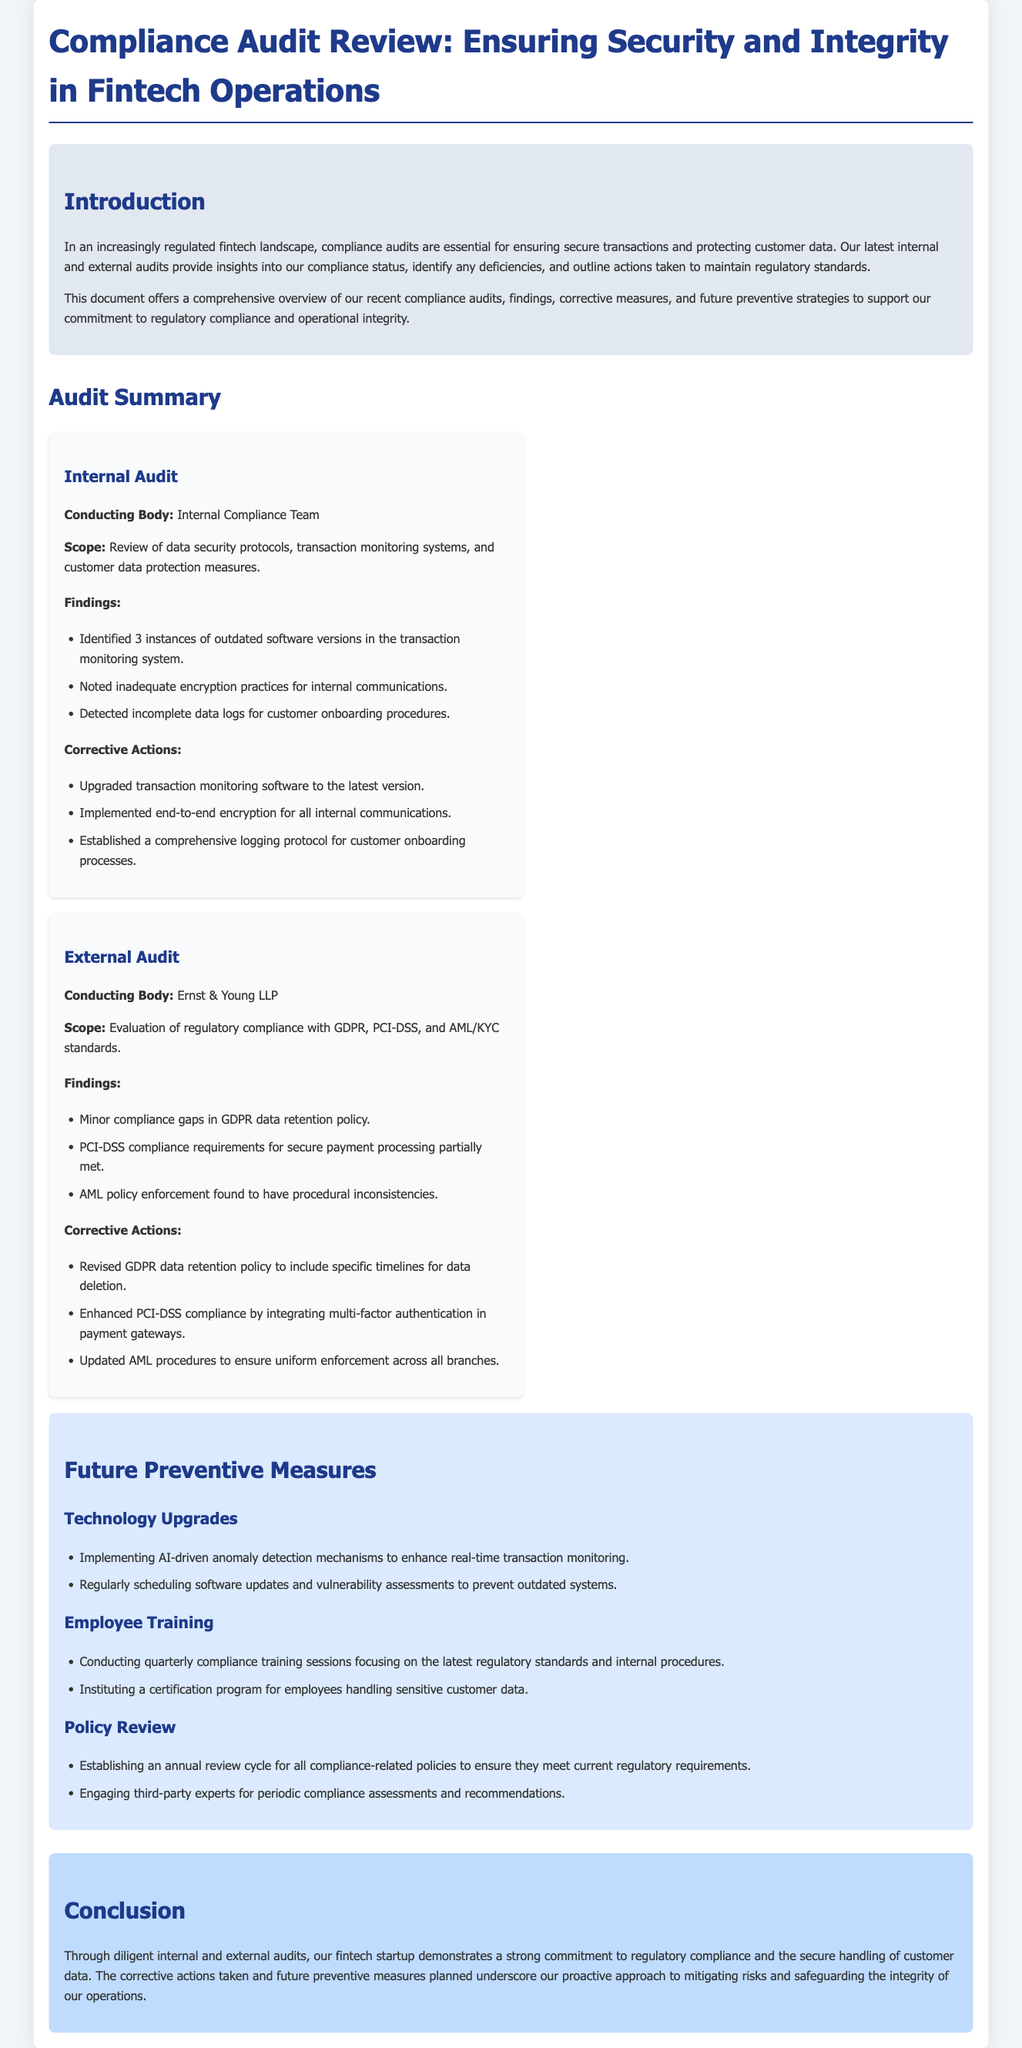What is the conducting body of the internal audit? The internal audit was conducted by the Internal Compliance Team as stated in the audit summary section.
Answer: Internal Compliance Team How many instances of outdated software were identified in the internal audit? The document mentions 3 instances of outdated software versions in the transaction monitoring system under internal audit findings.
Answer: 3 What are the two main regulatory standards mentioned in the external audit findings? The external audit findings mention GDPR and PCI-DSS as part of the evaluation of regulatory compliance.
Answer: GDPR, PCI-DSS What corrective action was taken regarding the GDPR data retention policy? The document states that the GDPR data retention policy was revised to include specific timelines for data deletion as a corrective measure.
Answer: Revised to include specific timelines What technology upgrade is planned for preventing outdated systems? The document outlines that regularly scheduling software updates and vulnerability assessments is a planned preventive measure for technology upgrades.
Answer: Regularly scheduling software updates What is the main focus of the quarterly compliance training sessions? The document specifies that the focus of quarterly compliance training sessions is on the latest regulatory standards and internal procedures.
Answer: Latest regulatory standards and internal procedures How often will compliance-related policies be reviewed? The document states that compliance-related policies will be reviewed annually to ensure they meet current regulatory requirements.
Answer: Annually What document type is this review classified as? The title and introduction indicate that this is a Compliance Audit Review document focused on internal and external audits in a fintech context.
Answer: Compliance Audit Review 